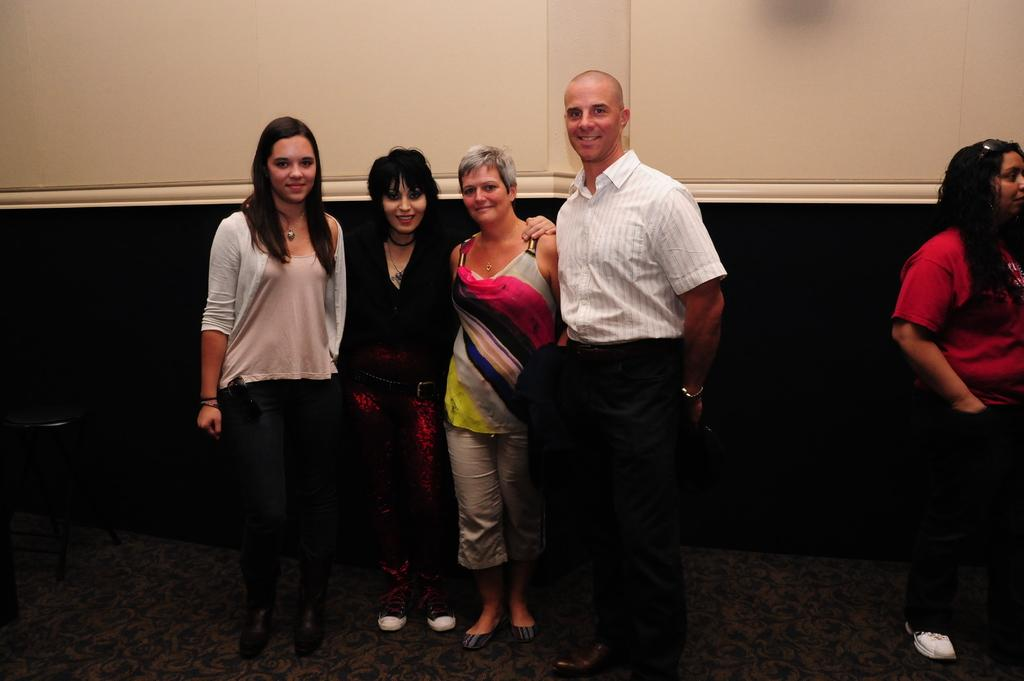How many people are in the image? There are people in the image, including at least one man and some women. What are the people in the image doing? The people in the image are smiling. What object can be seen in the image that might be used for sitting? There is a chair in the image. What songs are the people in the image singing? There is no indication in the image that the people are singing songs, so it cannot be determined from the picture. 